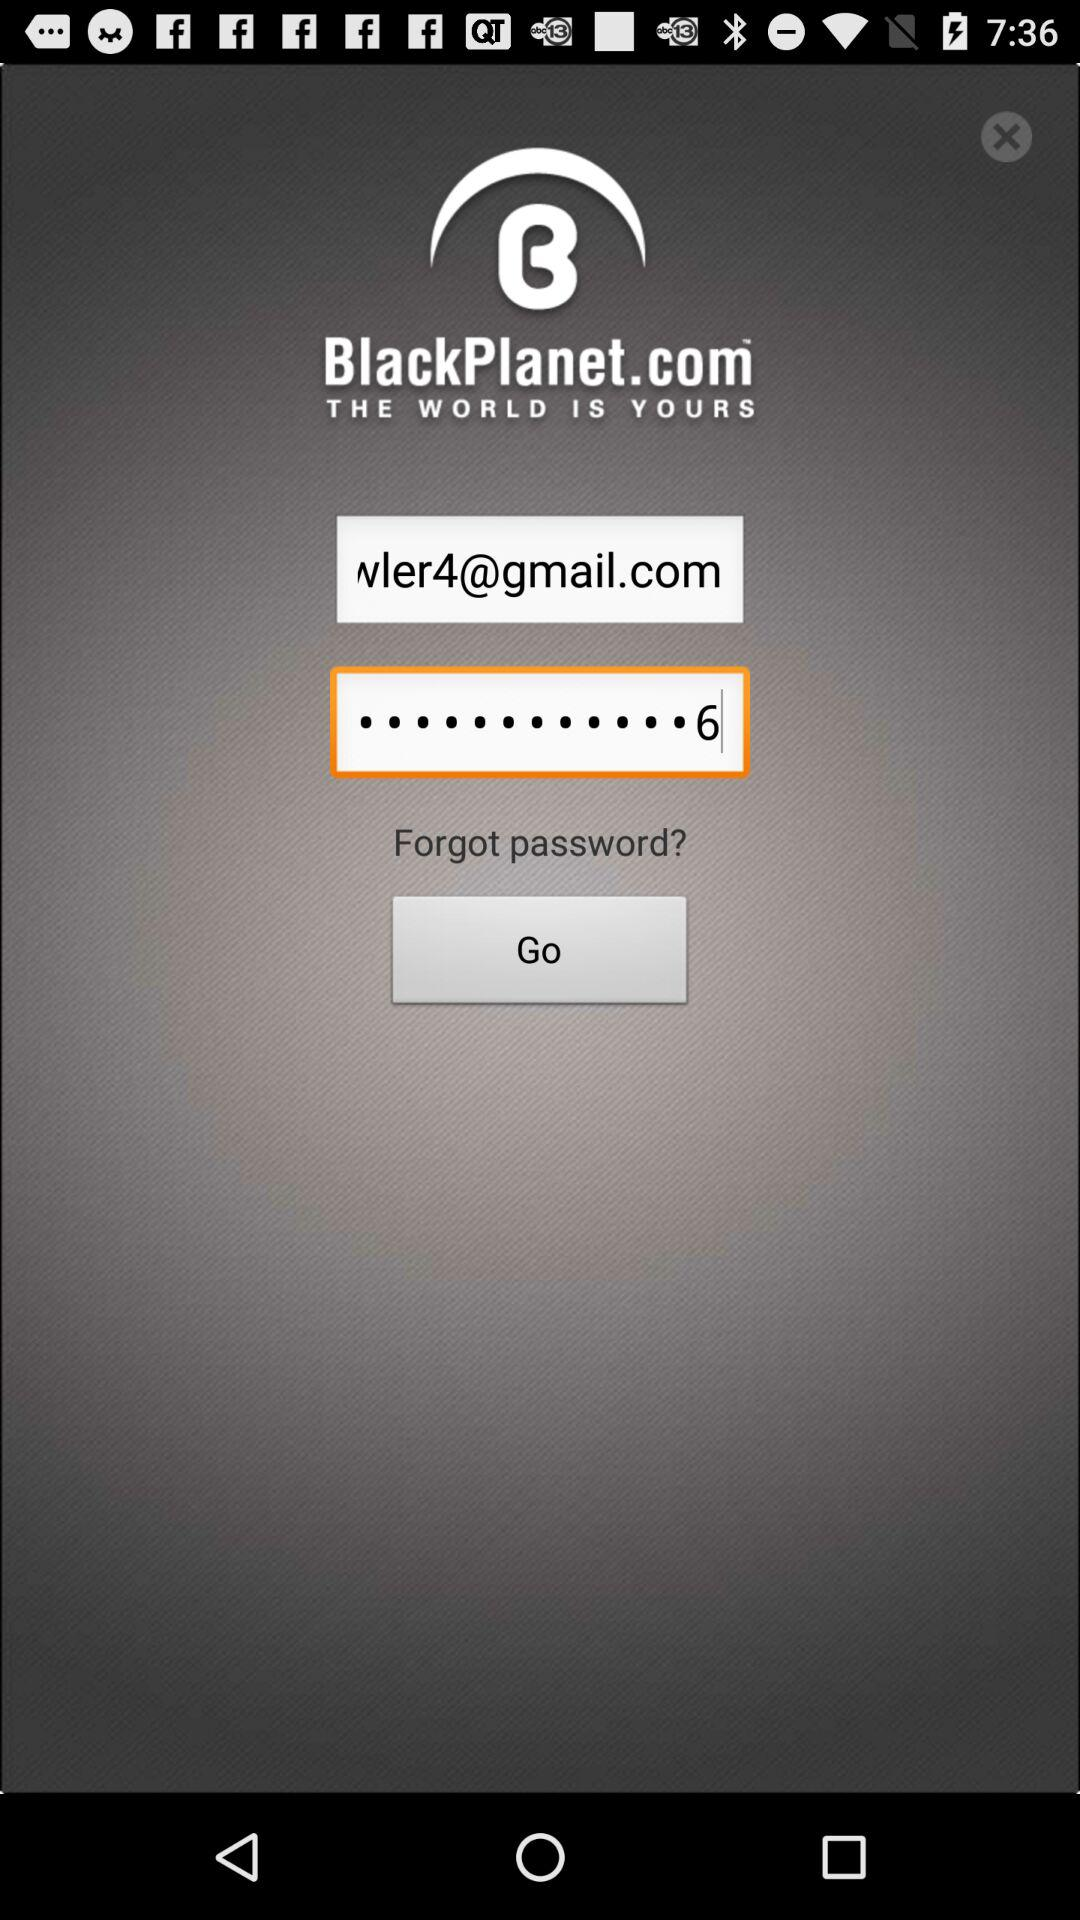What is the name of the application? The name of the application is "BlackPlanet". 